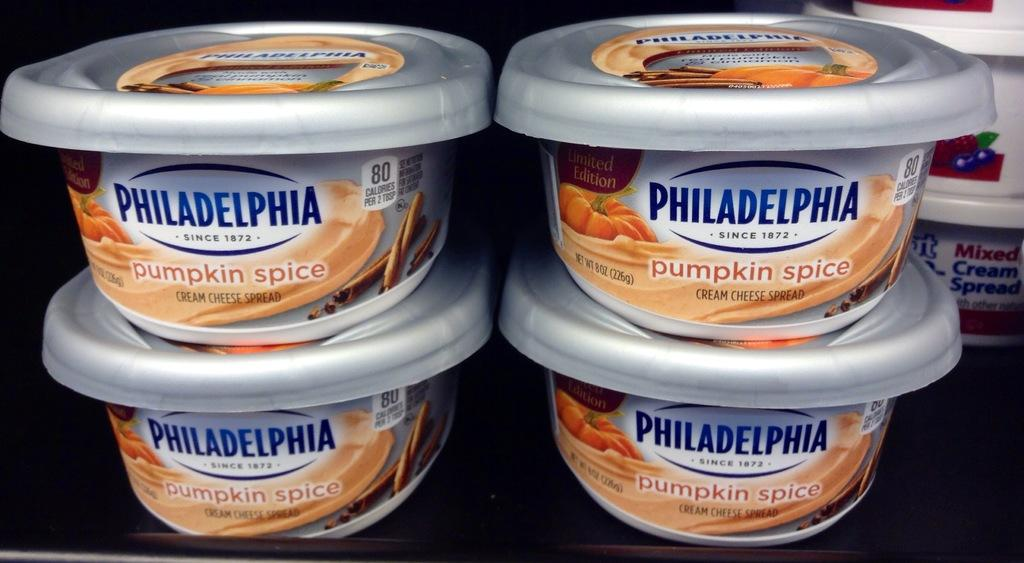What objects are located in the middle of the image? There are cups in the middle of the image. What information is provided on the cups? There are labels on the cups. What color is the crayon on the head of the person in the image? There is no person or crayon present in the image. 